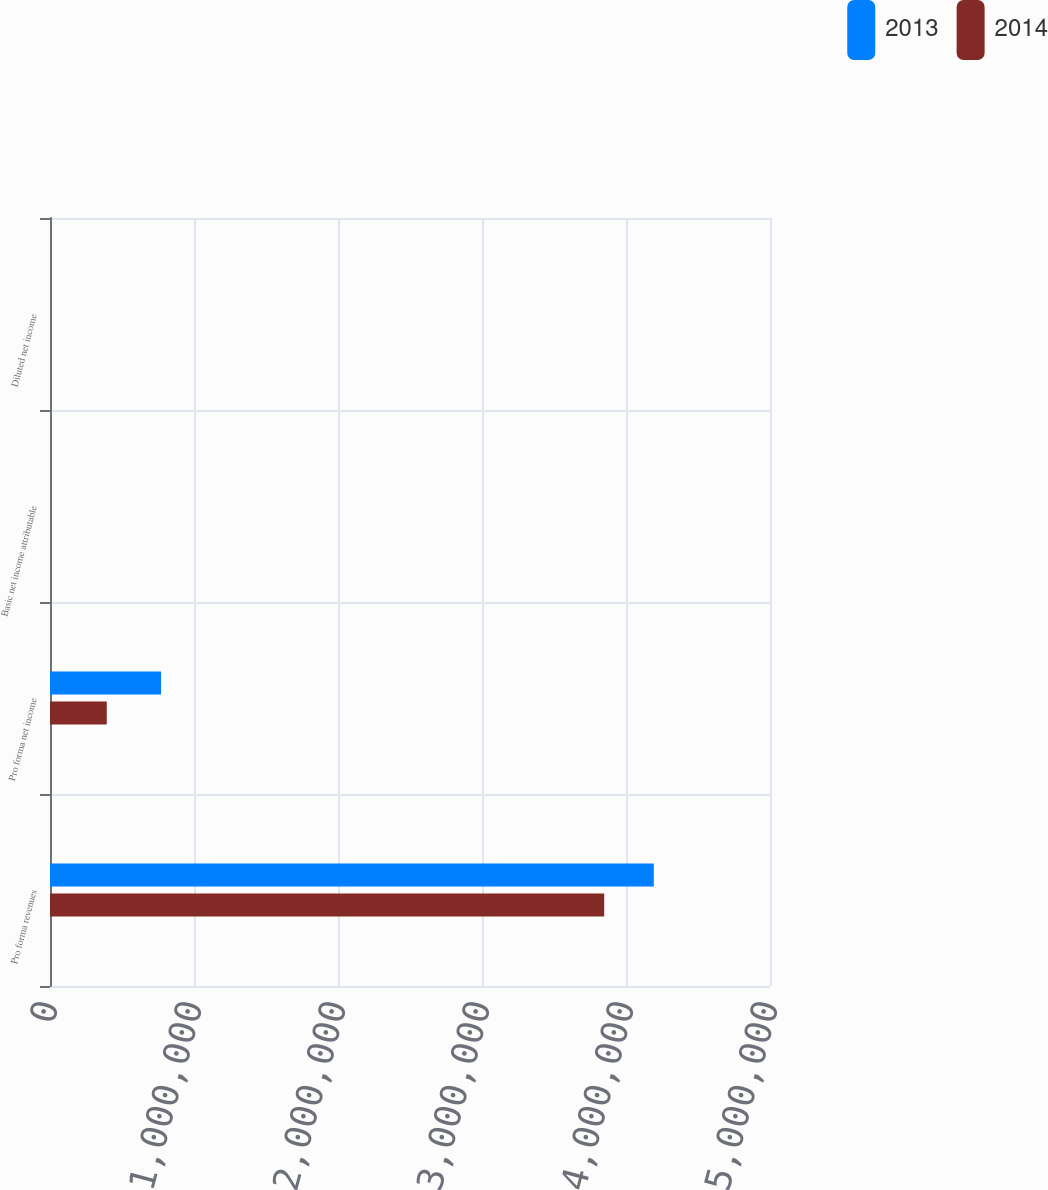Convert chart. <chart><loc_0><loc_0><loc_500><loc_500><stacked_bar_chart><ecel><fcel>Pro forma revenues<fcel>Pro forma net income<fcel>Basic net income attributable<fcel>Diluted net income<nl><fcel>2013<fcel>4.19307e+06<fcel>770871<fcel>1.95<fcel>1.93<nl><fcel>2014<fcel>3.84855e+06<fcel>394253<fcel>1<fcel>0.99<nl></chart> 